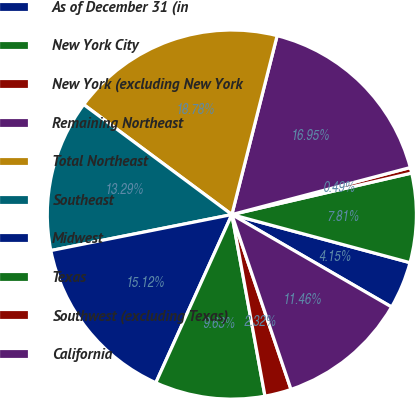<chart> <loc_0><loc_0><loc_500><loc_500><pie_chart><fcel>As of December 31 (in<fcel>New York City<fcel>New York (excluding New York<fcel>Remaining Northeast<fcel>Total Northeast<fcel>Southeast<fcel>Midwest<fcel>Texas<fcel>Southwest (excluding Texas)<fcel>California<nl><fcel>4.15%<fcel>7.81%<fcel>0.49%<fcel>16.95%<fcel>18.78%<fcel>13.29%<fcel>15.12%<fcel>9.63%<fcel>2.32%<fcel>11.46%<nl></chart> 